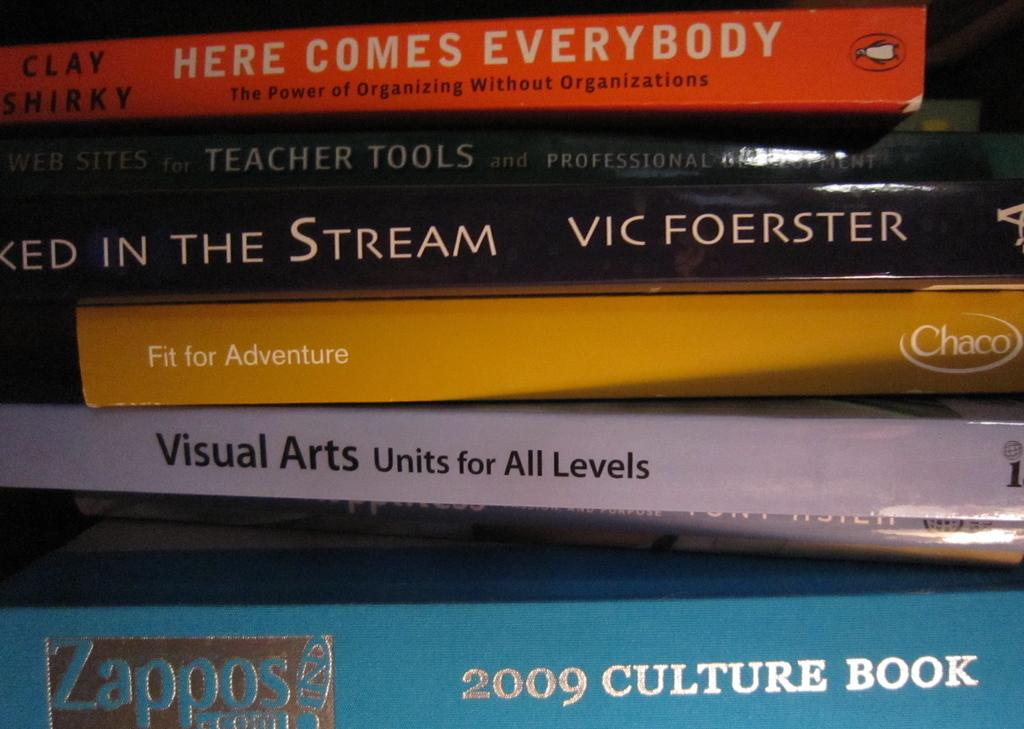<image>
Create a compact narrative representing the image presented. the year 2009 is on the side of the book 